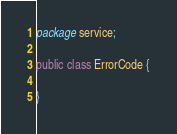Convert code to text. <code><loc_0><loc_0><loc_500><loc_500><_Java_>package service;

public class ErrorCode {

}
</code> 